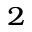<formula> <loc_0><loc_0><loc_500><loc_500>_ { 2 }</formula> 